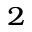<formula> <loc_0><loc_0><loc_500><loc_500>_ { 2 }</formula> 